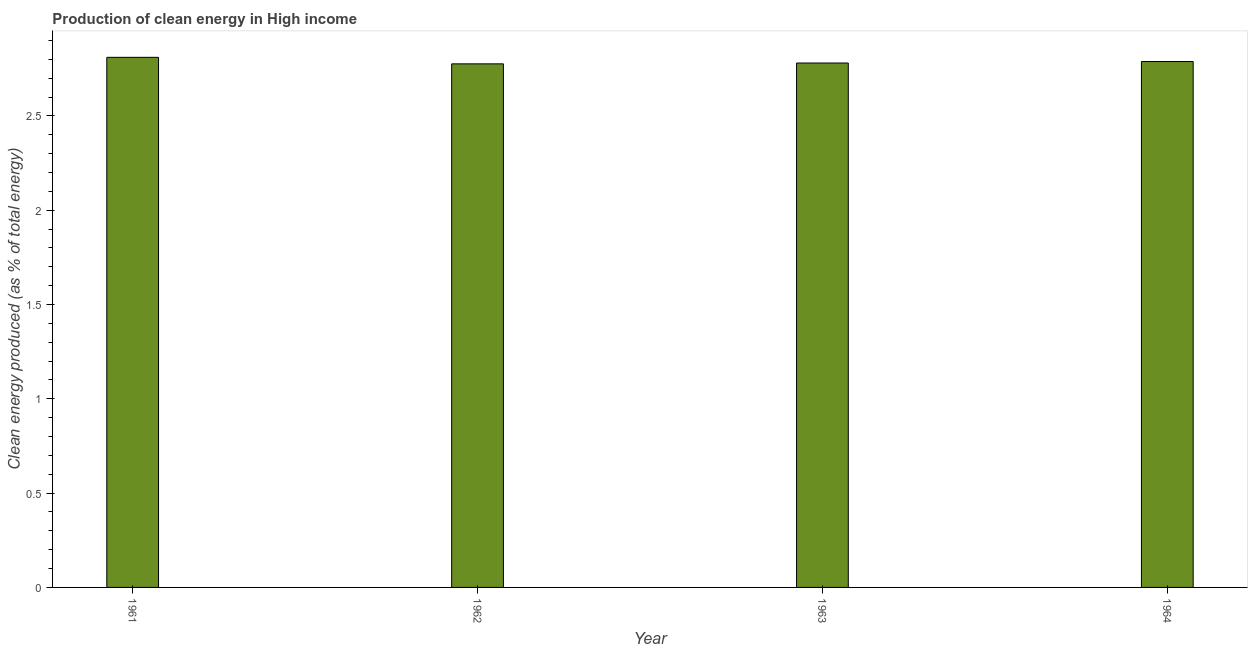Does the graph contain any zero values?
Offer a terse response. No. What is the title of the graph?
Make the answer very short. Production of clean energy in High income. What is the label or title of the X-axis?
Ensure brevity in your answer.  Year. What is the label or title of the Y-axis?
Your answer should be very brief. Clean energy produced (as % of total energy). What is the production of clean energy in 1962?
Your answer should be compact. 2.78. Across all years, what is the maximum production of clean energy?
Keep it short and to the point. 2.81. Across all years, what is the minimum production of clean energy?
Provide a succinct answer. 2.78. In which year was the production of clean energy minimum?
Offer a very short reply. 1962. What is the sum of the production of clean energy?
Provide a succinct answer. 11.16. What is the difference between the production of clean energy in 1961 and 1962?
Give a very brief answer. 0.04. What is the average production of clean energy per year?
Provide a succinct answer. 2.79. What is the median production of clean energy?
Your answer should be very brief. 2.78. In how many years, is the production of clean energy greater than 1.6 %?
Provide a succinct answer. 4. What is the ratio of the production of clean energy in 1963 to that in 1964?
Provide a short and direct response. 1. Is the production of clean energy in 1962 less than that in 1964?
Offer a very short reply. Yes. What is the difference between the highest and the second highest production of clean energy?
Ensure brevity in your answer.  0.02. Is the sum of the production of clean energy in 1961 and 1964 greater than the maximum production of clean energy across all years?
Your response must be concise. Yes. In how many years, is the production of clean energy greater than the average production of clean energy taken over all years?
Ensure brevity in your answer.  1. How many years are there in the graph?
Your answer should be compact. 4. What is the Clean energy produced (as % of total energy) of 1961?
Offer a very short reply. 2.81. What is the Clean energy produced (as % of total energy) of 1962?
Give a very brief answer. 2.78. What is the Clean energy produced (as % of total energy) of 1963?
Offer a terse response. 2.78. What is the Clean energy produced (as % of total energy) in 1964?
Your answer should be very brief. 2.79. What is the difference between the Clean energy produced (as % of total energy) in 1961 and 1962?
Provide a succinct answer. 0.03. What is the difference between the Clean energy produced (as % of total energy) in 1961 and 1963?
Your answer should be very brief. 0.03. What is the difference between the Clean energy produced (as % of total energy) in 1961 and 1964?
Ensure brevity in your answer.  0.02. What is the difference between the Clean energy produced (as % of total energy) in 1962 and 1963?
Provide a succinct answer. -0. What is the difference between the Clean energy produced (as % of total energy) in 1962 and 1964?
Offer a very short reply. -0.01. What is the difference between the Clean energy produced (as % of total energy) in 1963 and 1964?
Your response must be concise. -0.01. What is the ratio of the Clean energy produced (as % of total energy) in 1961 to that in 1962?
Give a very brief answer. 1.01. What is the ratio of the Clean energy produced (as % of total energy) in 1961 to that in 1963?
Your answer should be very brief. 1.01. What is the ratio of the Clean energy produced (as % of total energy) in 1962 to that in 1963?
Your answer should be compact. 1. What is the ratio of the Clean energy produced (as % of total energy) in 1963 to that in 1964?
Give a very brief answer. 1. 